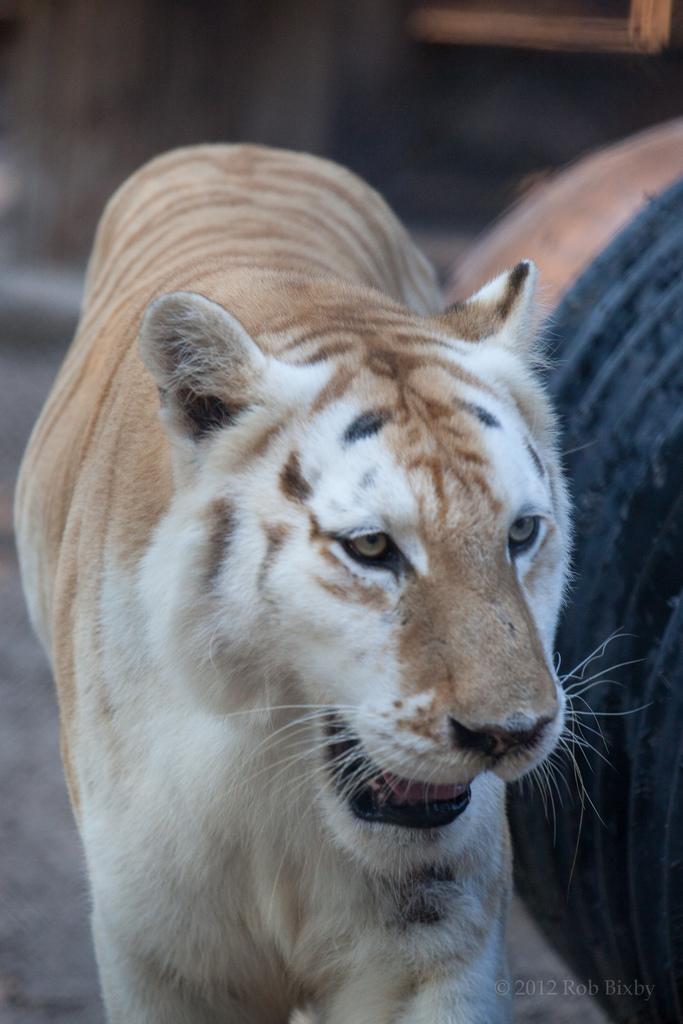Please provide a concise description of this image. In this image I can see a tiger which is white and brown in color is standing. I can see a black colored object and the blurry background. 